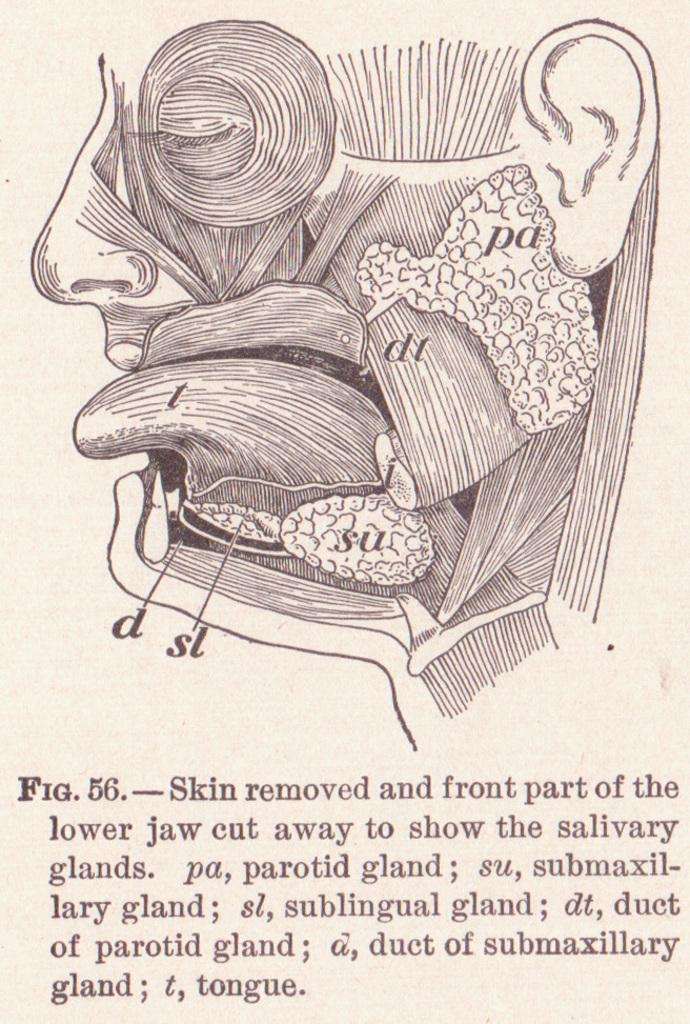What is the main subject of the image? The main subject of the image is a picture of the internal parts of the face. Is there any text accompanying the image? Yes, there is a paragraph below the picture. How many rays can be seen emanating from the spot in the image? There are no rays or spots present in the image; it features a picture of the internal parts of the face. 